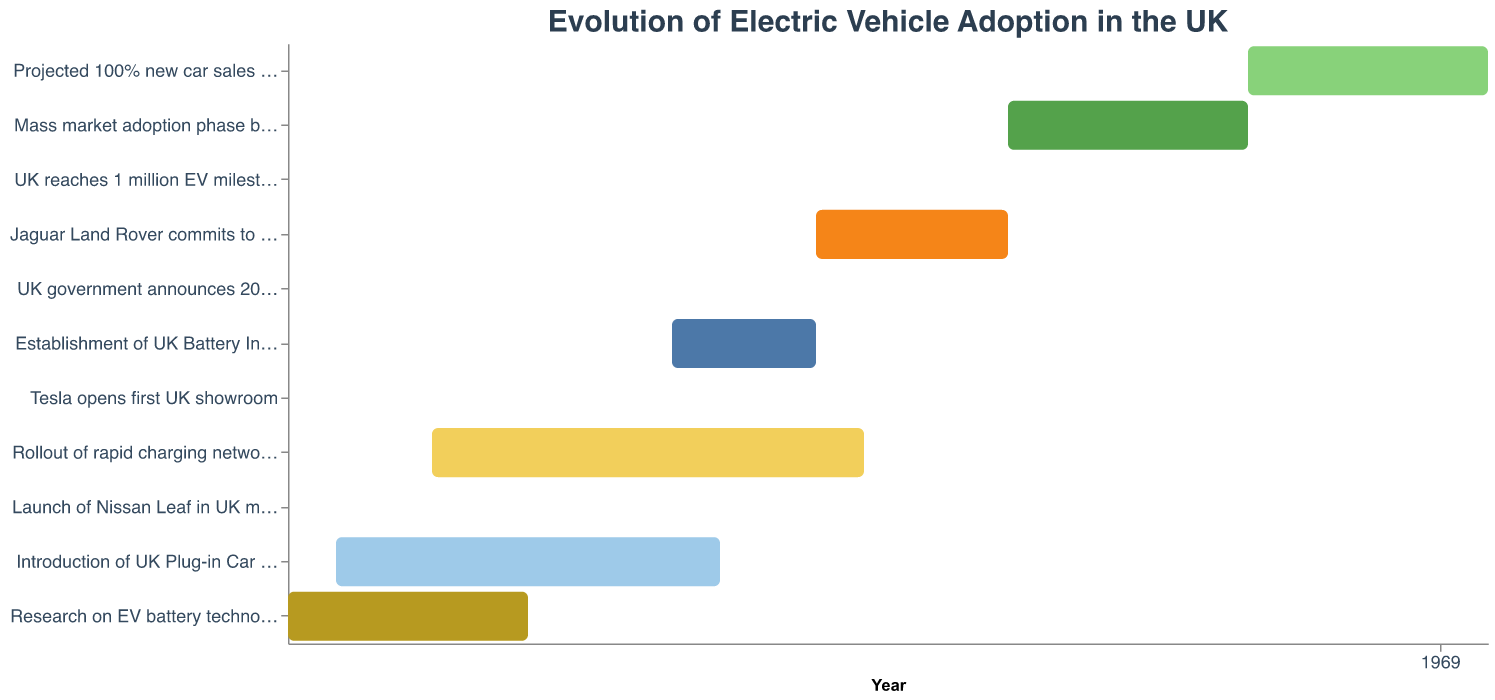What is the title of the chart? The title of the chart is located at the top and is displayed in larger font compared to other text. By visually identifying the header, we can see the chart's title.
Answer: Evolution of Electric Vehicle Adoption in the UK Which task spans the longest duration in the given chart? By scanning the tasks on the y-axis and observing the length of the bars on the x-axis, we can compare the duration of each task. The "Rollout of rapid charging networks by BP Chargemaster" has the longest bar extending from 2013 to 2022.
Answer: Rollout of rapid charging networks by BP Chargemaster What is the starting year for the "Mass market adoption phase"? By locating the "Mass market adoption phase begins" task on the y-axis and tracing it to the x-axis, we note that the bar indicates the beginning year.
Answer: 2025 How many years did it take for the UK to reach 1 million EVs after the establishment of the UK Battery Industrialisation Centre? First identify the end year of the "Establishment of UK Battery Industrialisation Centre" which is 2021, and the year the UK reached 1 million EVs, which is 2023. The difference between these years gives the duration. 2023 - 2021 = 2 years.
Answer: 2 years During which years did the "Introduction of UK Plug-in Car Grant" take place? Locate the "Introduction of UK Plug-in Car Grant" on the y-axis and observe its start and end points on the x-axis. The bar indicates it started in 2011 and ended in 2019.
Answer: 2011 to 2019 Which task started immediately after "Research on EV battery technology"? Look at the end year of "Research on EV battery technology" which is 2015, and then identify the task that started immediately in the following available year. Since the next start year is 2018 for the "Establishment of UK Battery Industrialisation Centre," we recognize this task.
Answer: Establishment of UK Battery Industrialisation Centre Compare the duration of "Jaguar Land Rover commits to all-electric lineup" with "UK reaches 1 million EV milestone." Which one has a longer duration? Identify the start and end years for both tasks: "Jaguar Land Rover commits to all-electric lineup" (2021 to 2025) spans 4 years, while "UK reaches 1 million EV milestone" is a milestone event, lasting only 2023. Compare these durations.
Answer: Jaguar Land Rover commits to all-electric lineup What is the projected end year for achieving 100% new car sales to be electric? Locate the "Projected 100% new car sales to be electric" task on the y-axis, and note the end year by tracing to the x-axis.
Answer: 2035 Which event marks a specific year without spanning multiple years? Scan through the tasks and identify those with the same start and end year. Examples include "UK government announces 2030 ban on new petrol/diesel cars" which occurred only in 2020, "Launch of Nissan Leaf in UK market" in 2011, "Tesla opens first UK showroom" in 2013, and "UK reaches 1 million EV milestone" in 2023.
Answer: UK government announces 2030 ban on new petrol/diesel cars and others In what year did rapid charging networks by BP Chargemaster start to roll out? Find the "Rollout of rapid charging networks by BP Chargemaster" task on the y-axis and note its start year by tracing to the x-axis.
Answer: 2013 